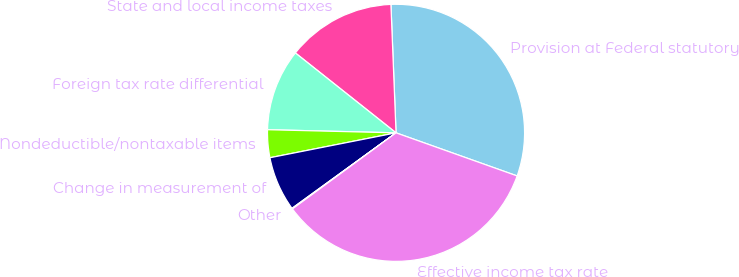<chart> <loc_0><loc_0><loc_500><loc_500><pie_chart><fcel>Provision at Federal statutory<fcel>State and local income taxes<fcel>Foreign tax rate differential<fcel>Nondeductible/nontaxable items<fcel>Change in measurement of<fcel>Other<fcel>Effective income tax rate<nl><fcel>31.08%<fcel>13.69%<fcel>10.29%<fcel>3.49%<fcel>6.89%<fcel>0.09%<fcel>34.48%<nl></chart> 